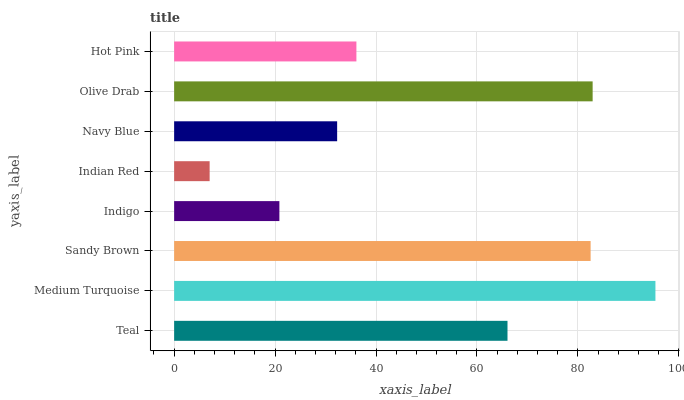Is Indian Red the minimum?
Answer yes or no. Yes. Is Medium Turquoise the maximum?
Answer yes or no. Yes. Is Sandy Brown the minimum?
Answer yes or no. No. Is Sandy Brown the maximum?
Answer yes or no. No. Is Medium Turquoise greater than Sandy Brown?
Answer yes or no. Yes. Is Sandy Brown less than Medium Turquoise?
Answer yes or no. Yes. Is Sandy Brown greater than Medium Turquoise?
Answer yes or no. No. Is Medium Turquoise less than Sandy Brown?
Answer yes or no. No. Is Teal the high median?
Answer yes or no. Yes. Is Hot Pink the low median?
Answer yes or no. Yes. Is Sandy Brown the high median?
Answer yes or no. No. Is Teal the low median?
Answer yes or no. No. 